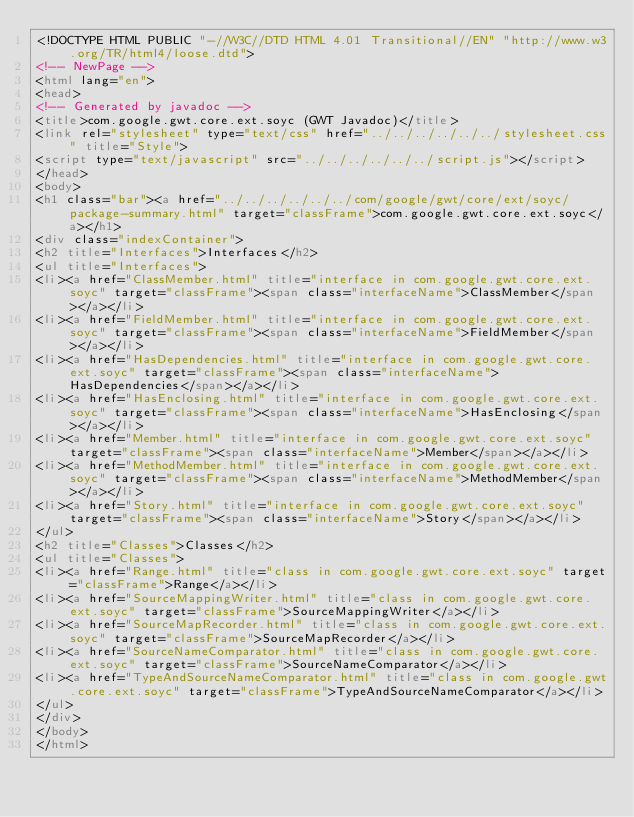Convert code to text. <code><loc_0><loc_0><loc_500><loc_500><_HTML_><!DOCTYPE HTML PUBLIC "-//W3C//DTD HTML 4.01 Transitional//EN" "http://www.w3.org/TR/html4/loose.dtd">
<!-- NewPage -->
<html lang="en">
<head>
<!-- Generated by javadoc -->
<title>com.google.gwt.core.ext.soyc (GWT Javadoc)</title>
<link rel="stylesheet" type="text/css" href="../../../../../../stylesheet.css" title="Style">
<script type="text/javascript" src="../../../../../../script.js"></script>
</head>
<body>
<h1 class="bar"><a href="../../../../../../com/google/gwt/core/ext/soyc/package-summary.html" target="classFrame">com.google.gwt.core.ext.soyc</a></h1>
<div class="indexContainer">
<h2 title="Interfaces">Interfaces</h2>
<ul title="Interfaces">
<li><a href="ClassMember.html" title="interface in com.google.gwt.core.ext.soyc" target="classFrame"><span class="interfaceName">ClassMember</span></a></li>
<li><a href="FieldMember.html" title="interface in com.google.gwt.core.ext.soyc" target="classFrame"><span class="interfaceName">FieldMember</span></a></li>
<li><a href="HasDependencies.html" title="interface in com.google.gwt.core.ext.soyc" target="classFrame"><span class="interfaceName">HasDependencies</span></a></li>
<li><a href="HasEnclosing.html" title="interface in com.google.gwt.core.ext.soyc" target="classFrame"><span class="interfaceName">HasEnclosing</span></a></li>
<li><a href="Member.html" title="interface in com.google.gwt.core.ext.soyc" target="classFrame"><span class="interfaceName">Member</span></a></li>
<li><a href="MethodMember.html" title="interface in com.google.gwt.core.ext.soyc" target="classFrame"><span class="interfaceName">MethodMember</span></a></li>
<li><a href="Story.html" title="interface in com.google.gwt.core.ext.soyc" target="classFrame"><span class="interfaceName">Story</span></a></li>
</ul>
<h2 title="Classes">Classes</h2>
<ul title="Classes">
<li><a href="Range.html" title="class in com.google.gwt.core.ext.soyc" target="classFrame">Range</a></li>
<li><a href="SourceMappingWriter.html" title="class in com.google.gwt.core.ext.soyc" target="classFrame">SourceMappingWriter</a></li>
<li><a href="SourceMapRecorder.html" title="class in com.google.gwt.core.ext.soyc" target="classFrame">SourceMapRecorder</a></li>
<li><a href="SourceNameComparator.html" title="class in com.google.gwt.core.ext.soyc" target="classFrame">SourceNameComparator</a></li>
<li><a href="TypeAndSourceNameComparator.html" title="class in com.google.gwt.core.ext.soyc" target="classFrame">TypeAndSourceNameComparator</a></li>
</ul>
</div>
</body>
</html>
</code> 